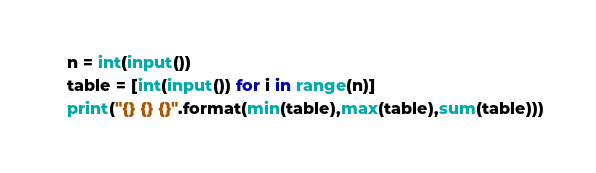<code> <loc_0><loc_0><loc_500><loc_500><_Python_>n = int(input())
table = [int(input()) for i in range(n)]
print("{} {} {}".format(min(table),max(table),sum(table)))
</code> 